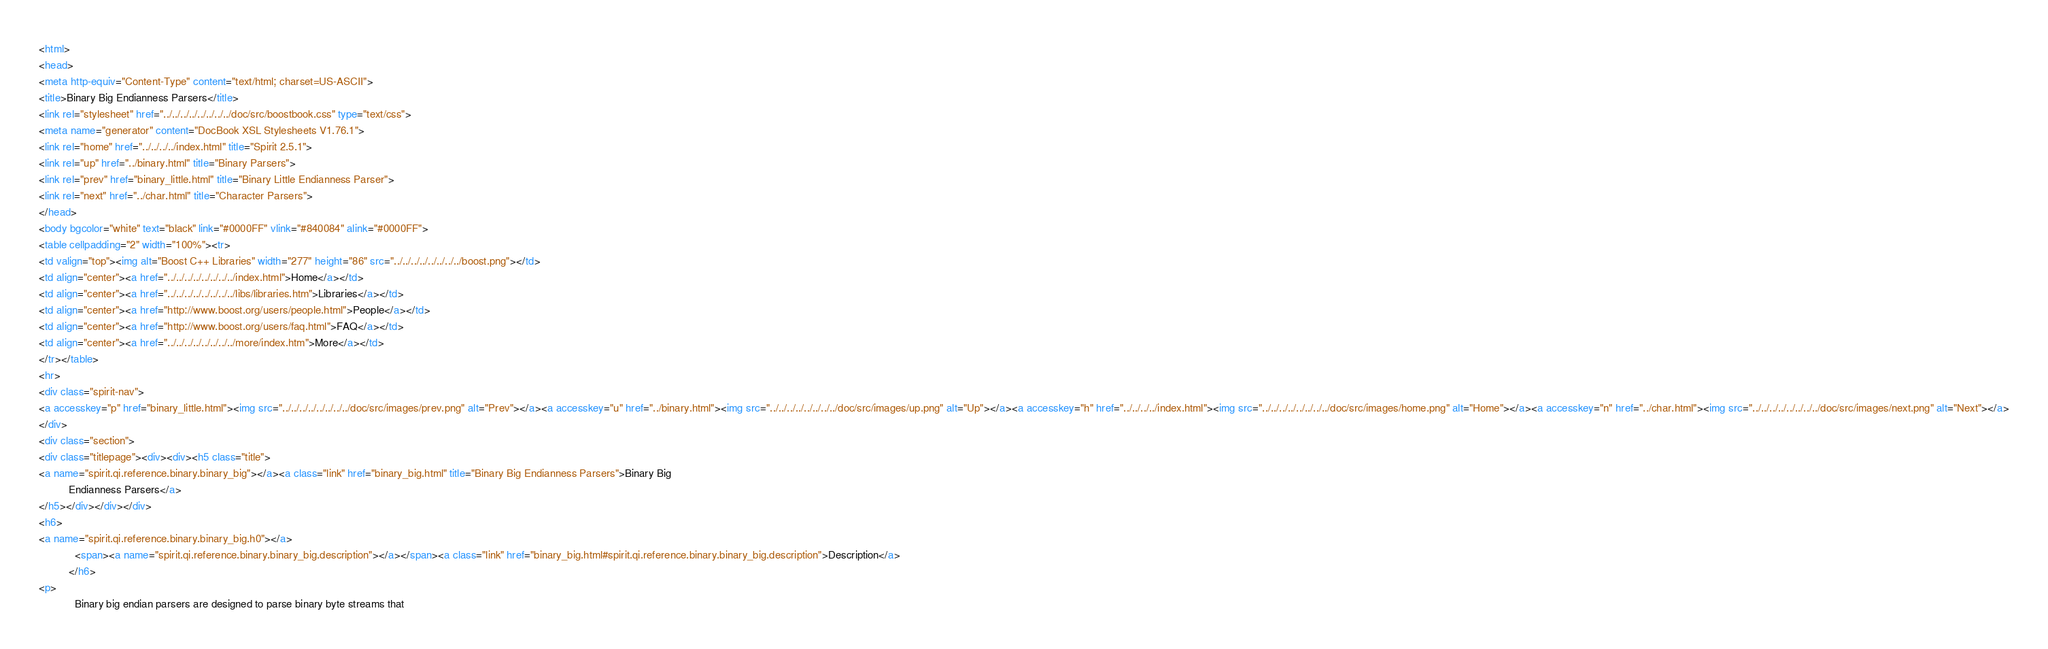<code> <loc_0><loc_0><loc_500><loc_500><_HTML_><html>
<head>
<meta http-equiv="Content-Type" content="text/html; charset=US-ASCII">
<title>Binary Big Endianness Parsers</title>
<link rel="stylesheet" href="../../../../../../../../doc/src/boostbook.css" type="text/css">
<meta name="generator" content="DocBook XSL Stylesheets V1.76.1">
<link rel="home" href="../../../../index.html" title="Spirit 2.5.1">
<link rel="up" href="../binary.html" title="Binary Parsers">
<link rel="prev" href="binary_little.html" title="Binary Little Endianness Parser">
<link rel="next" href="../char.html" title="Character Parsers">
</head>
<body bgcolor="white" text="black" link="#0000FF" vlink="#840084" alink="#0000FF">
<table cellpadding="2" width="100%"><tr>
<td valign="top"><img alt="Boost C++ Libraries" width="277" height="86" src="../../../../../../../../boost.png"></td>
<td align="center"><a href="../../../../../../../../index.html">Home</a></td>
<td align="center"><a href="../../../../../../../../libs/libraries.htm">Libraries</a></td>
<td align="center"><a href="http://www.boost.org/users/people.html">People</a></td>
<td align="center"><a href="http://www.boost.org/users/faq.html">FAQ</a></td>
<td align="center"><a href="../../../../../../../../more/index.htm">More</a></td>
</tr></table>
<hr>
<div class="spirit-nav">
<a accesskey="p" href="binary_little.html"><img src="../../../../../../../../doc/src/images/prev.png" alt="Prev"></a><a accesskey="u" href="../binary.html"><img src="../../../../../../../../doc/src/images/up.png" alt="Up"></a><a accesskey="h" href="../../../../index.html"><img src="../../../../../../../../doc/src/images/home.png" alt="Home"></a><a accesskey="n" href="../char.html"><img src="../../../../../../../../doc/src/images/next.png" alt="Next"></a>
</div>
<div class="section">
<div class="titlepage"><div><div><h5 class="title">
<a name="spirit.qi.reference.binary.binary_big"></a><a class="link" href="binary_big.html" title="Binary Big Endianness Parsers">Binary Big
          Endianness Parsers</a>
</h5></div></div></div>
<h6>
<a name="spirit.qi.reference.binary.binary_big.h0"></a>
            <span><a name="spirit.qi.reference.binary.binary_big.description"></a></span><a class="link" href="binary_big.html#spirit.qi.reference.binary.binary_big.description">Description</a>
          </h6>
<p>
            Binary big endian parsers are designed to parse binary byte streams that</code> 